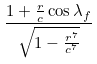Convert formula to latex. <formula><loc_0><loc_0><loc_500><loc_500>\frac { 1 + \frac { r } { c } \cos \lambda _ { f } } { \sqrt { 1 - \frac { r ^ { 7 } } { c ^ { 7 } } } }</formula> 